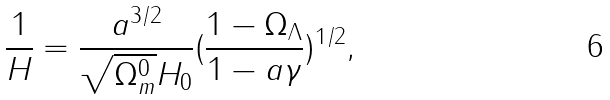Convert formula to latex. <formula><loc_0><loc_0><loc_500><loc_500>\frac { 1 } { H } = \frac { a ^ { 3 / 2 } } { \sqrt { \Omega _ { m } ^ { 0 } } H _ { 0 } } ( \frac { 1 - { \Omega _ { \Lambda } } } { 1 - a \gamma } ) ^ { 1 / 2 } ,</formula> 